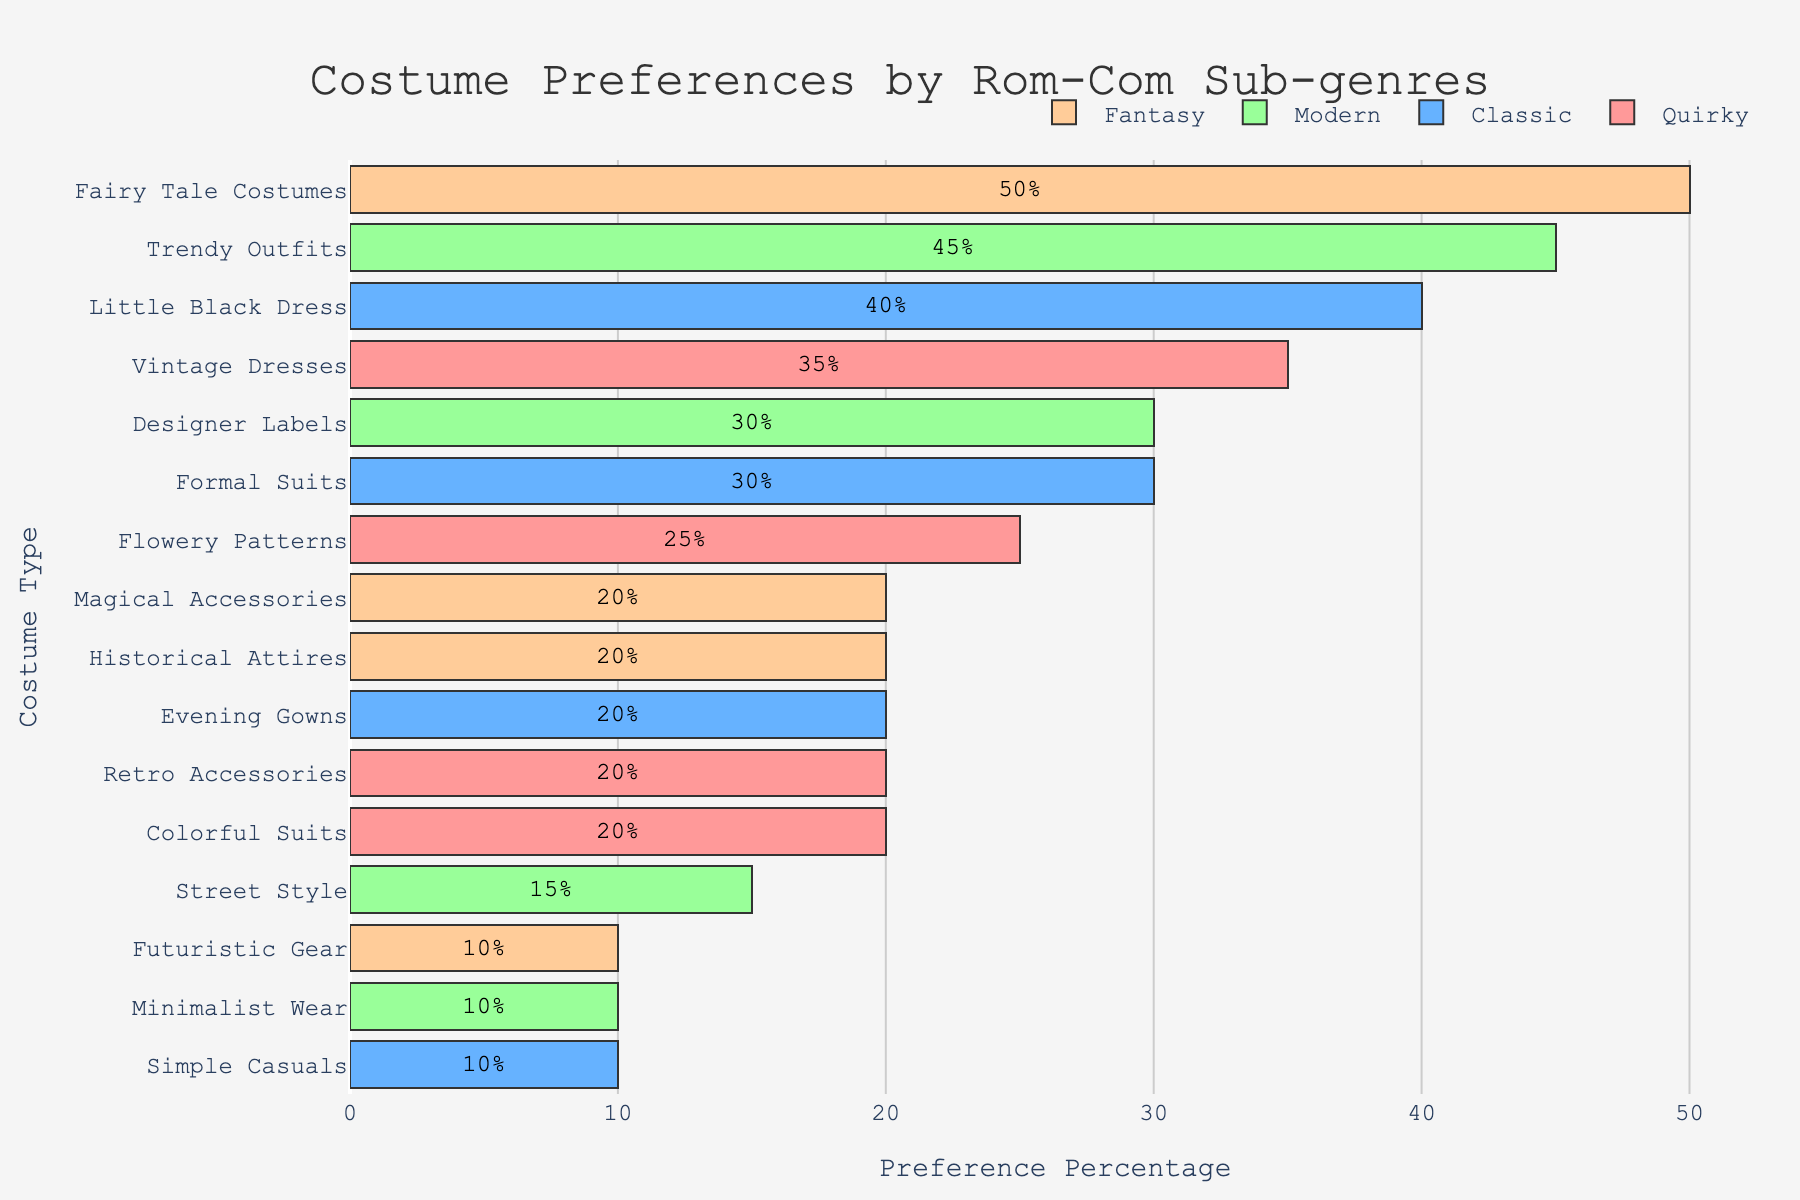What is the most preferred costume type in the Fantasy sub-genre? Scan the Fantasy sub-genre bars, identify and compare their lengths. The longest bar represents the most preferred costume. The "Fairy Tale Costumes" bar is the longest.
Answer: Fairy Tale Costumes Which sub-genre has the highest percentage of a single costume type? Identify the bar with the highest percentage across all sub-genres. "Fairy Tale Costumes" in the Fantasy sub-genre has 50%, which is the highest.
Answer: Fantasy What is the total preference percentage for quirky sub-genre costume types "Vintage Dresses" and "Flowery Patterns"? Look at the Quirky sub-genre, find the percentages for "Vintage Dresses" (35%) and "Flowery Patterns" (25%), then sum them: 35 + 25 = 60%
Answer: 60% Which sub-genre shows the least preference for "Retro Accessories"? Locate "Retro Accessories" across all sub-genres. It only appears under Quirky with 20%.
Answer: Quirky How does the preference for "Trendy Outfits" in the Modern sub-genre compare to "Little Black Dress" in the Classic sub-genre? Locate both bars, "Trendy Outfits" in Modern (45%), "Little Black Dress" in Classic (40%). Compare their lengths: 45% > 40%.
Answer: Trendy Outfits is higher What is the combined preference percentage for "Magical Accessories" and "Futuristic Gear" in the Fantasy sub-genre? Add the percentages for "Magical Accessories" (20%) and "Futuristic Gear" (10%) in Fantasy: 20 + 10 = 30%.
Answer: 30% Which sub-genre has the broadest range of preference percentages among its costume types? Locate each sub-genre, find the range (maximum - minimum percentage). Quirky: 35 - 20, Classic: 40 - 10, Modern: 45 - 10, Fantasy: 50 - 10. Fantasy has the largest range (50 - 10 = 40).
Answer: Fantasy What is the least preferred costume type in the Modern sub-genre? In Modern, compare the bars to find the shortest one. "Minimalist Wear" has the smallest percentage (10%).
Answer: Minimalist Wear 